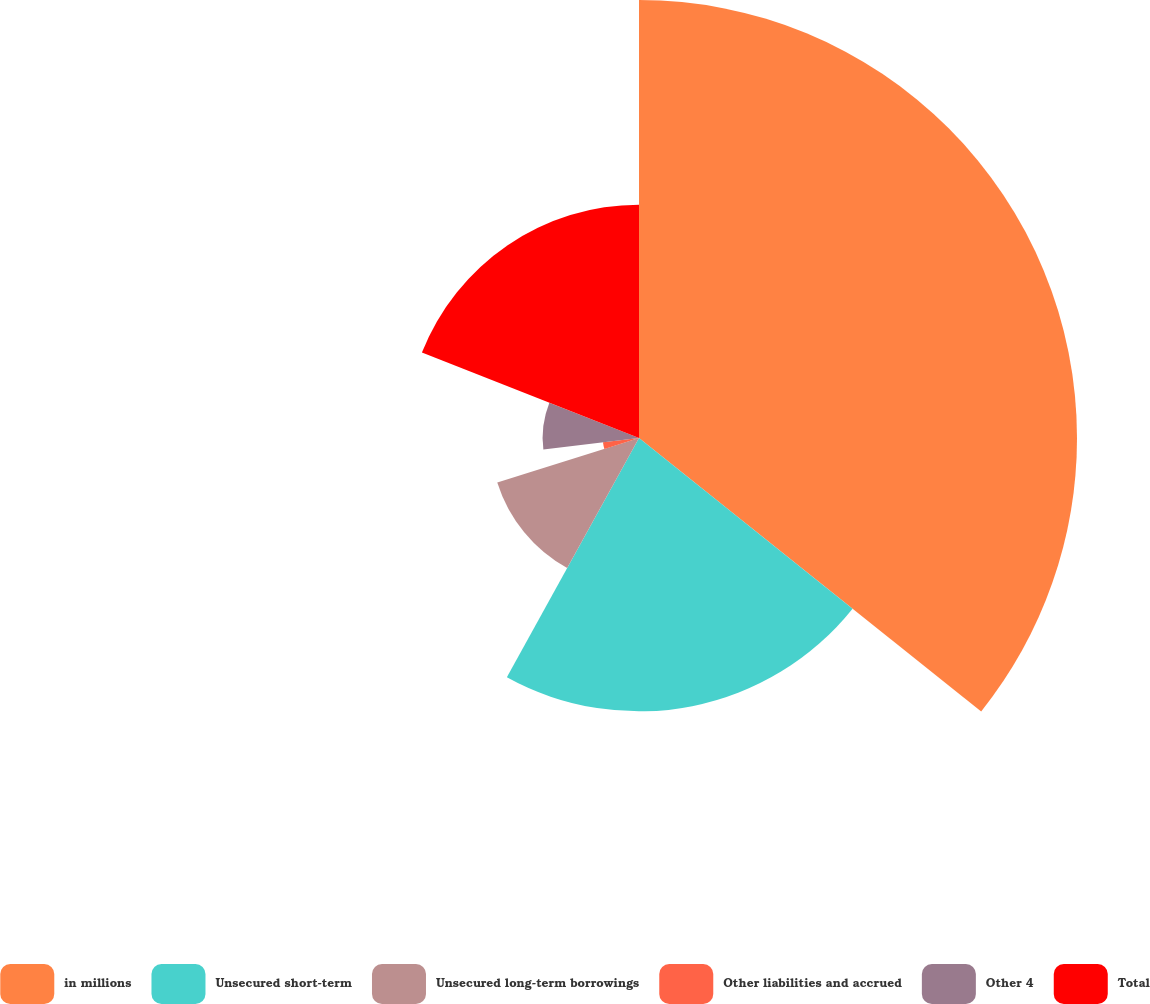<chart> <loc_0><loc_0><loc_500><loc_500><pie_chart><fcel>in millions<fcel>Unsecured short-term<fcel>Unsecured long-term borrowings<fcel>Other liabilities and accrued<fcel>Other 4<fcel>Total<nl><fcel>35.73%<fcel>22.3%<fcel>12.12%<fcel>2.96%<fcel>7.86%<fcel>19.03%<nl></chart> 